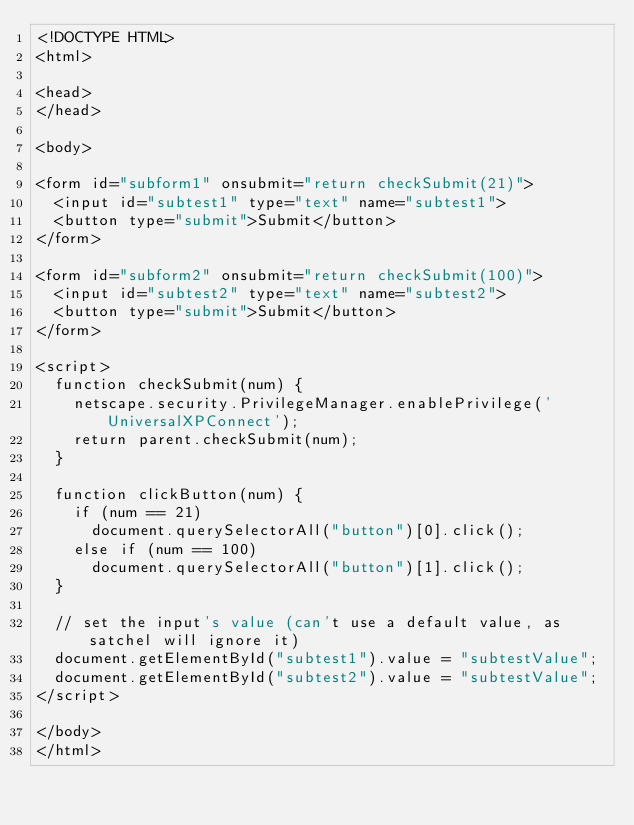Convert code to text. <code><loc_0><loc_0><loc_500><loc_500><_HTML_><!DOCTYPE HTML>
<html>

<head>
</head>

<body>

<form id="subform1" onsubmit="return checkSubmit(21)">
  <input id="subtest1" type="text" name="subtest1">
  <button type="submit">Submit</button>
</form>

<form id="subform2" onsubmit="return checkSubmit(100)">
  <input id="subtest2" type="text" name="subtest2">
  <button type="submit">Submit</button>
</form>

<script>
  function checkSubmit(num) {
    netscape.security.PrivilegeManager.enablePrivilege('UniversalXPConnect');
    return parent.checkSubmit(num);
  }

  function clickButton(num) {
    if (num == 21)
      document.querySelectorAll("button")[0].click();
    else if (num == 100)
      document.querySelectorAll("button")[1].click();
  }

  // set the input's value (can't use a default value, as satchel will ignore it)
  document.getElementById("subtest1").value = "subtestValue";
  document.getElementById("subtest2").value = "subtestValue";
</script>

</body>
</html>
</code> 